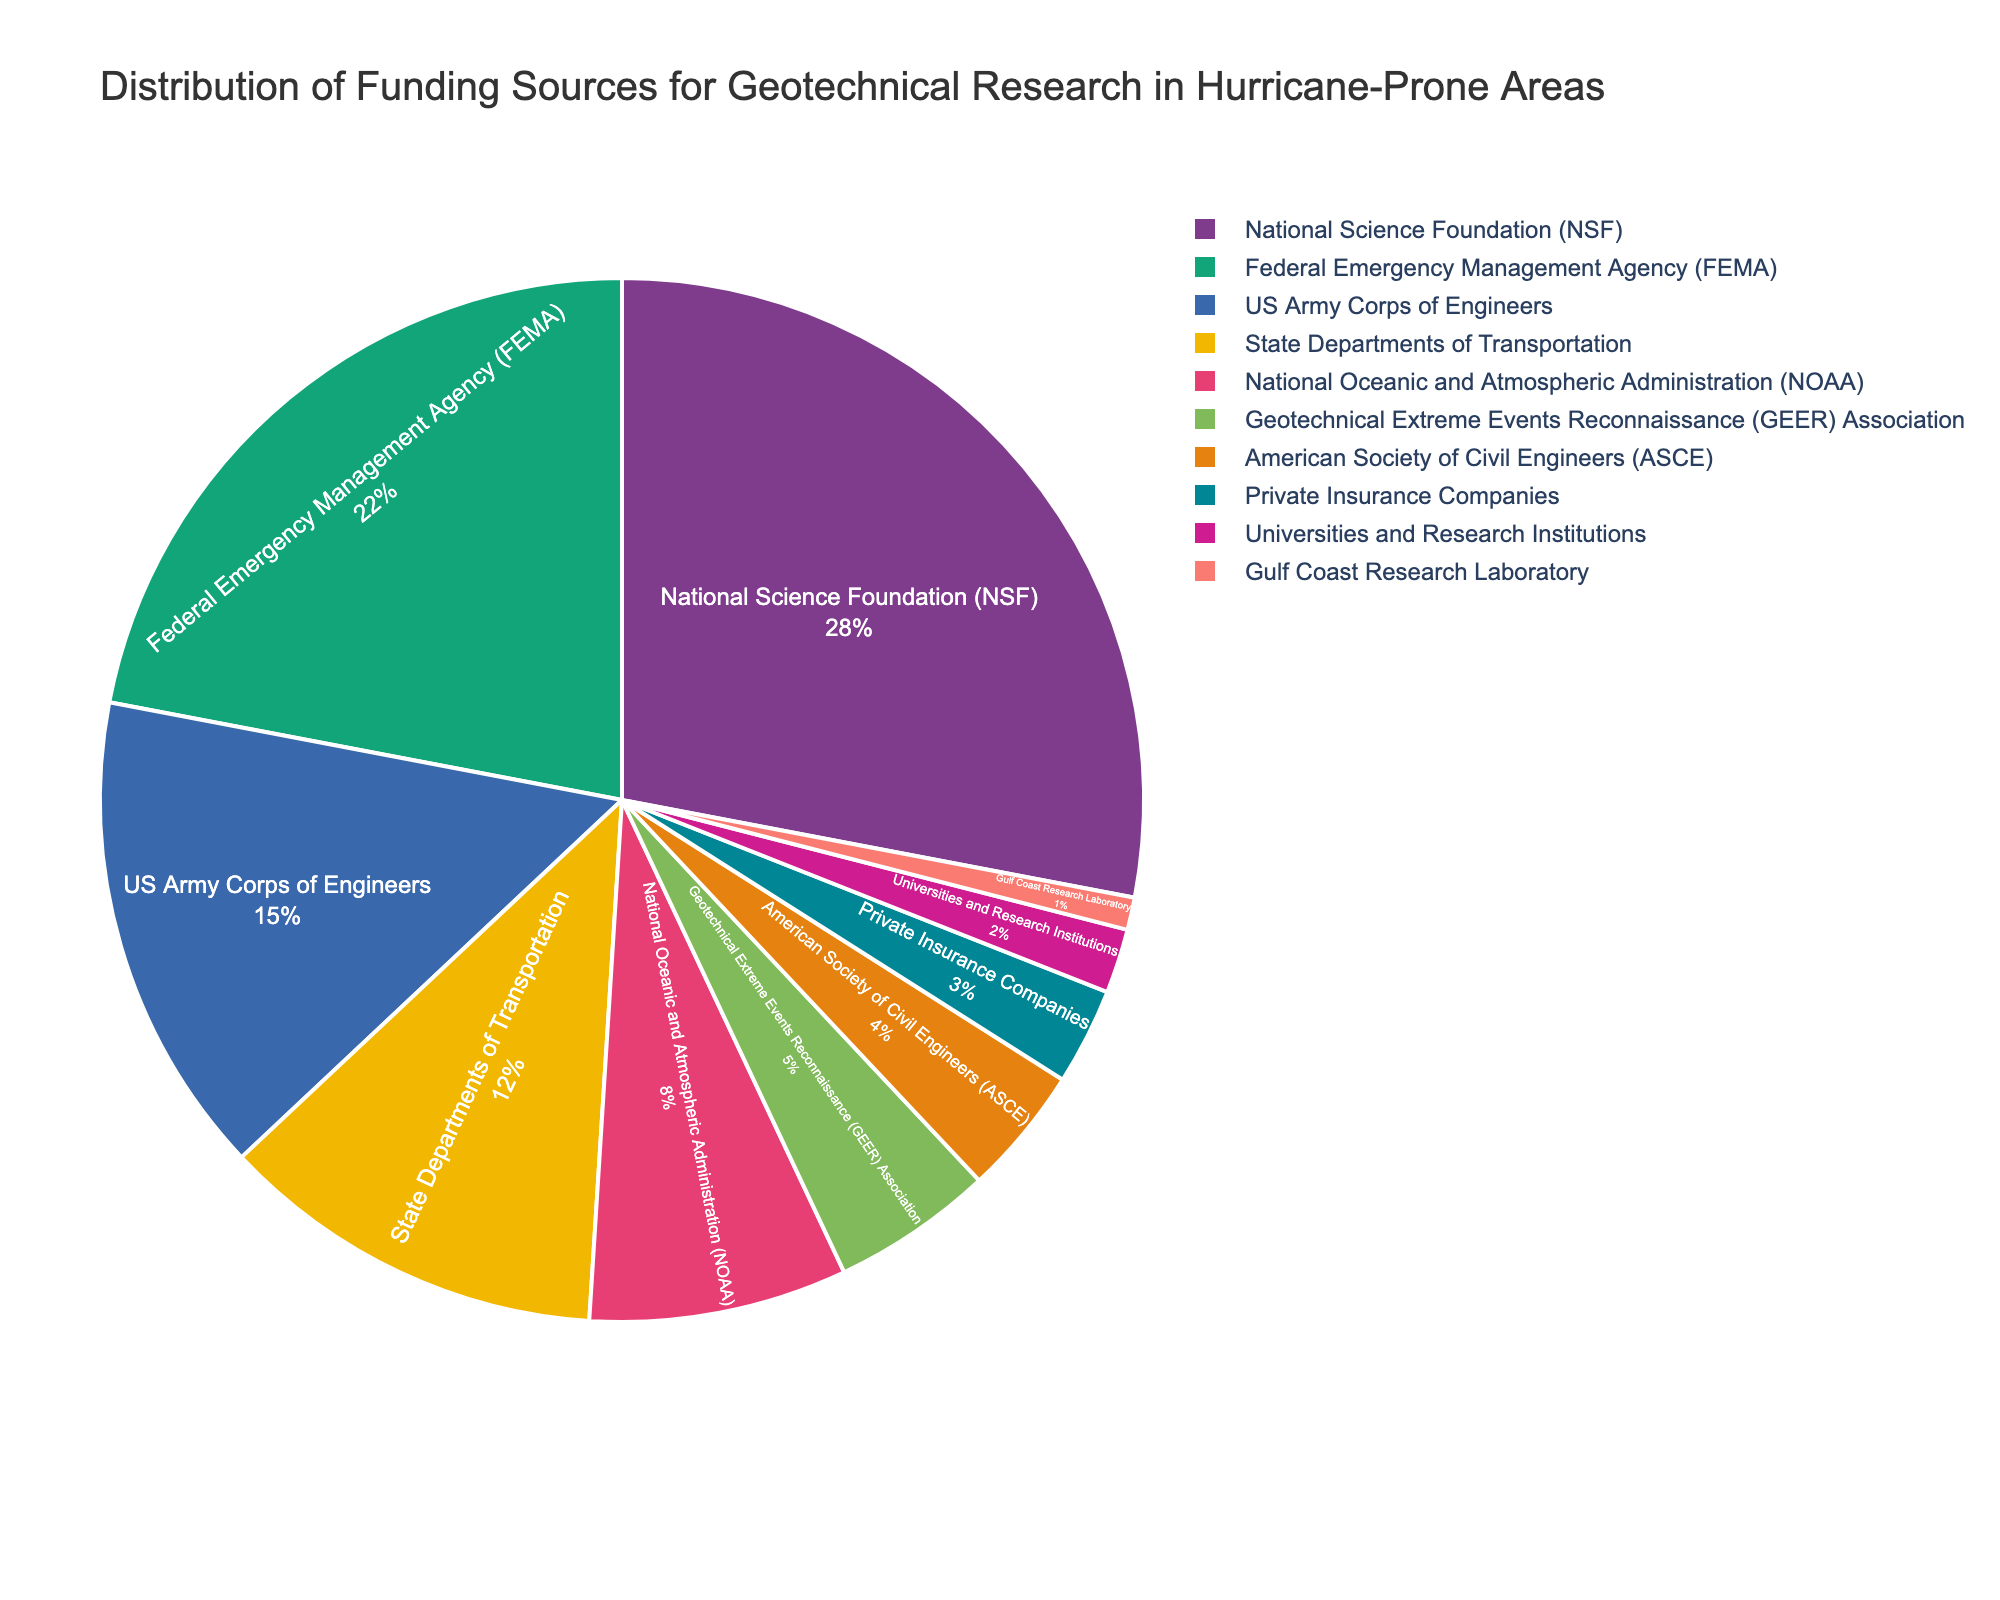What is the largest funding source for geotechnical research in hurricane-prone areas? The largest portion of the pie chart is labeled "National Science Foundation (NSF)" with 28%, indicating it is the largest funding source.
Answer: National Science Foundation (NSF) Which funding sources together contribute to more than half of the total funding? Adding the percentages of the largest funding sources: NSF (28%) + FEMA (22%) + US Army Corps of Engineers (15%) totals to 65%, which is more than half of the funding.
Answer: NSF, FEMA, US Army Corps of Engineers Which funding source contributes the least to geotechnical research in hurricane-prone areas? The smallest portion of the pie chart is labeled "Gulf Coast Research Laboratory" with 1%.
Answer: Gulf Coast Research Laboratory Is the funding provided by FEMA greater than the combined funding from State Departments of Transportation and NOAA? FEMA provides 22%, while State Departments of Transportation (12%) and NOAA (8%) together provide 20% (12% + 8%). Therefore, FEMA's funding is greater.
Answer: Yes Which funding source has a similar contribution to the National Oceanic and Atmospheric Administration (NOAA)? Both "Geotechnical Extreme Events Reconnaissance (GEER) Association" and "NOAA" have similar sized segments, but GEER is labeled with 5% and NOAA with 8%. Despite the visual similarity, the precise percentages are not the same.
Answer: None What is the combined percentage of funding from universities and research institutions and private insurance companies? Universities and Research Institutions contribute 2%, and Private Insurance Companies contribute 3%. Adding them yields 2% + 3% = 5%.
Answer: 5% Between the American Society of Civil Engineers (ASCE) and State Departments of Transportation, which one provides more funding? The pie chart shows ASCE provides 4% while State Departments of Transportation provide 12%. Thus, State Departments of Transportation provide more funding.
Answer: State Departments of Transportation How much more funding does the National Science Foundation (NSF) provide compared to the US Army Corps of Engineers? The NSF provides 28%, while the US Army Corps of Engineers provides 15%. The difference is 28% - 15% = 13%.
Answer: 13% Which three funding sources provide the smallest contributions, and what are their combined contributions? The smallest three segments are labeled: Gulf Coast Research Laboratory (1%), Universities and Research Institutions (2%), and Private Insurance Companies (3%). Their combined contribution is 1% + 2% + 3% = 6%.
Answer: Gulf Coast Research Laboratory, Universities and Research Institutions, Private Insurance Companies; 6% What is the combined funding percentage provided by NOAA and GEER Association? Adding the percentages of NOAA (8%) and GEER Association (5%), the combined total is 8% + 5% = 13%.
Answer: 13% 